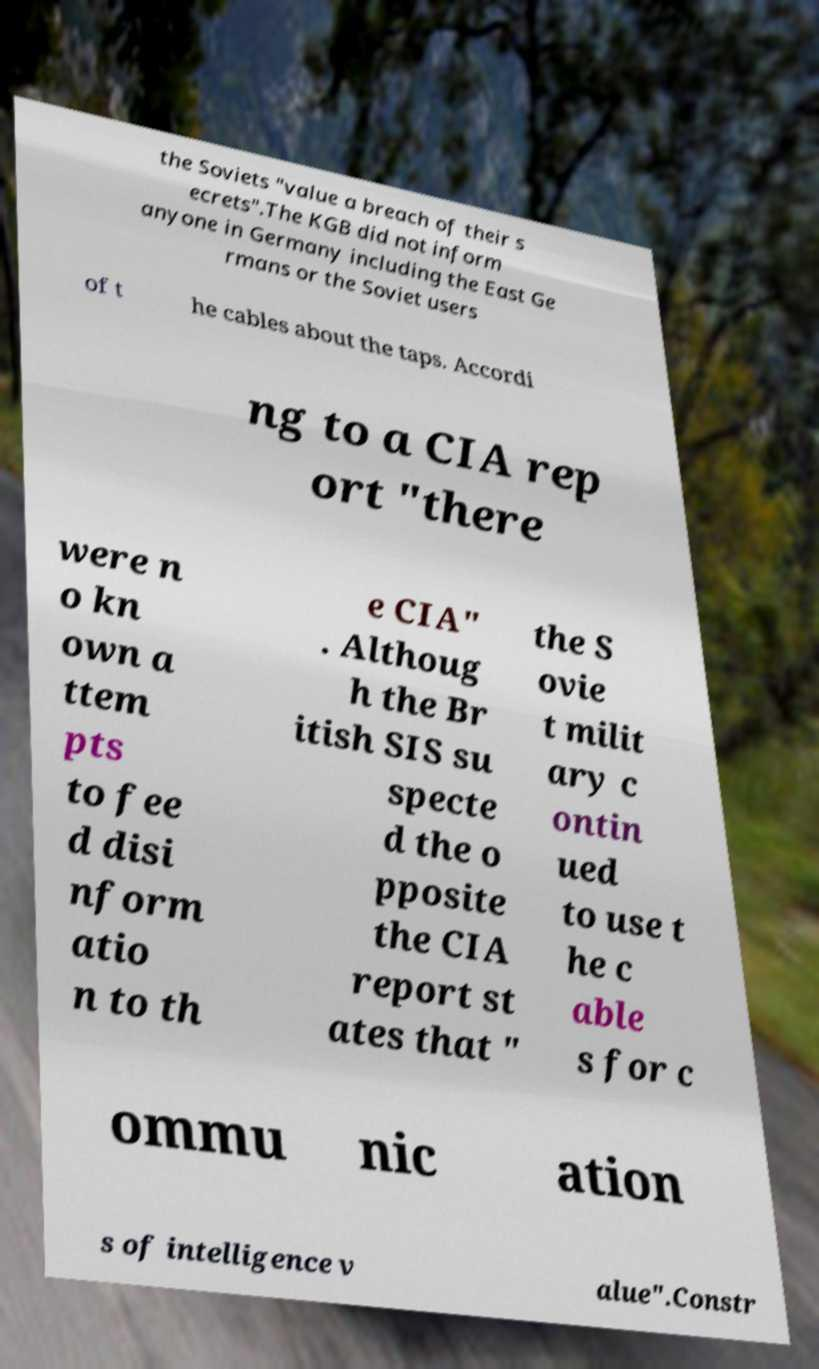What messages or text are displayed in this image? I need them in a readable, typed format. the Soviets "value a breach of their s ecrets".The KGB did not inform anyone in Germany including the East Ge rmans or the Soviet users of t he cables about the taps. Accordi ng to a CIA rep ort "there were n o kn own a ttem pts to fee d disi nform atio n to th e CIA" . Althoug h the Br itish SIS su specte d the o pposite the CIA report st ates that " the S ovie t milit ary c ontin ued to use t he c able s for c ommu nic ation s of intelligence v alue".Constr 